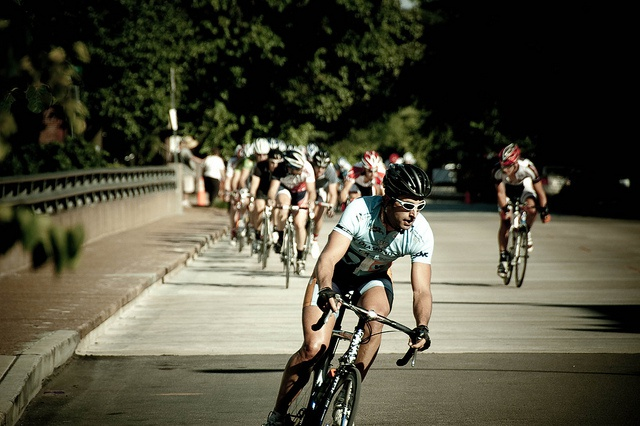Describe the objects in this image and their specific colors. I can see people in black, ivory, and tan tones, bicycle in black, gray, ivory, and beige tones, car in black, gray, darkgreen, and darkgray tones, people in black, maroon, and gray tones, and people in black, ivory, tan, and gray tones in this image. 